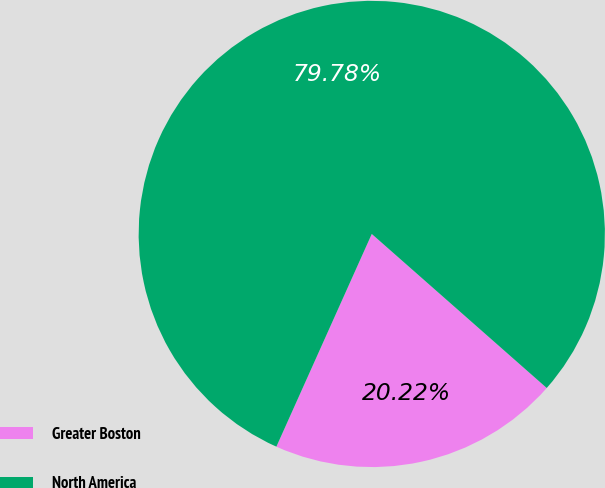Convert chart. <chart><loc_0><loc_0><loc_500><loc_500><pie_chart><fcel>Greater Boston<fcel>North America<nl><fcel>20.22%<fcel>79.78%<nl></chart> 